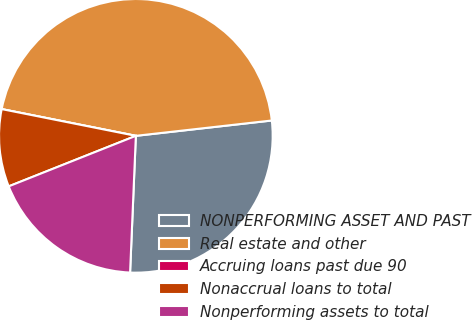Convert chart to OTSL. <chart><loc_0><loc_0><loc_500><loc_500><pie_chart><fcel>NONPERFORMING ASSET AND PAST<fcel>Real estate and other<fcel>Accruing loans past due 90<fcel>Nonaccrual loans to total<fcel>Nonperforming assets to total<nl><fcel>27.46%<fcel>45.08%<fcel>0.0%<fcel>9.15%<fcel>18.31%<nl></chart> 